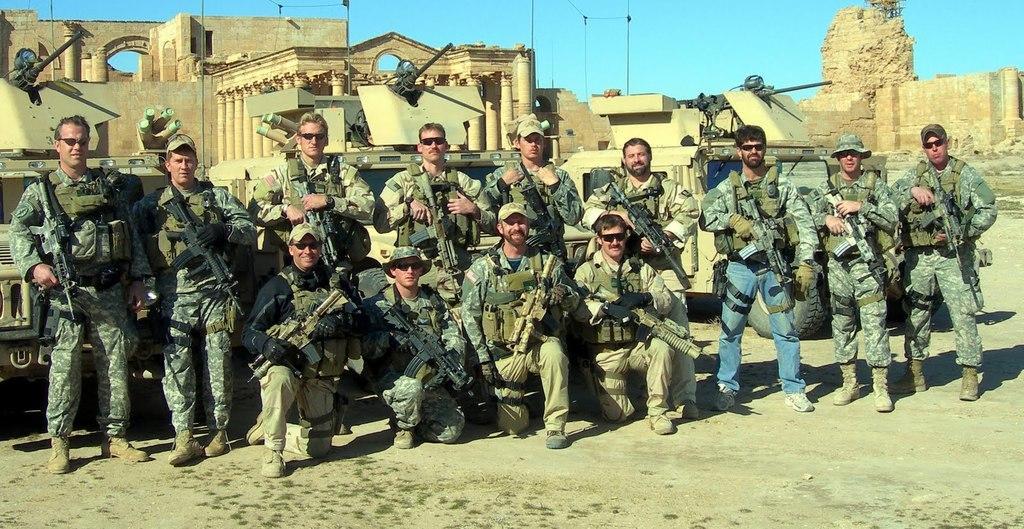Describe this image in one or two sentences. In this image in front there are four people sitting and they are holding the guns. Behind them there are a few people standing and they are holding the guns. There are canons. On the right side of the image there is a wall. In the background of the image there are buildings, poles and there is sky. 